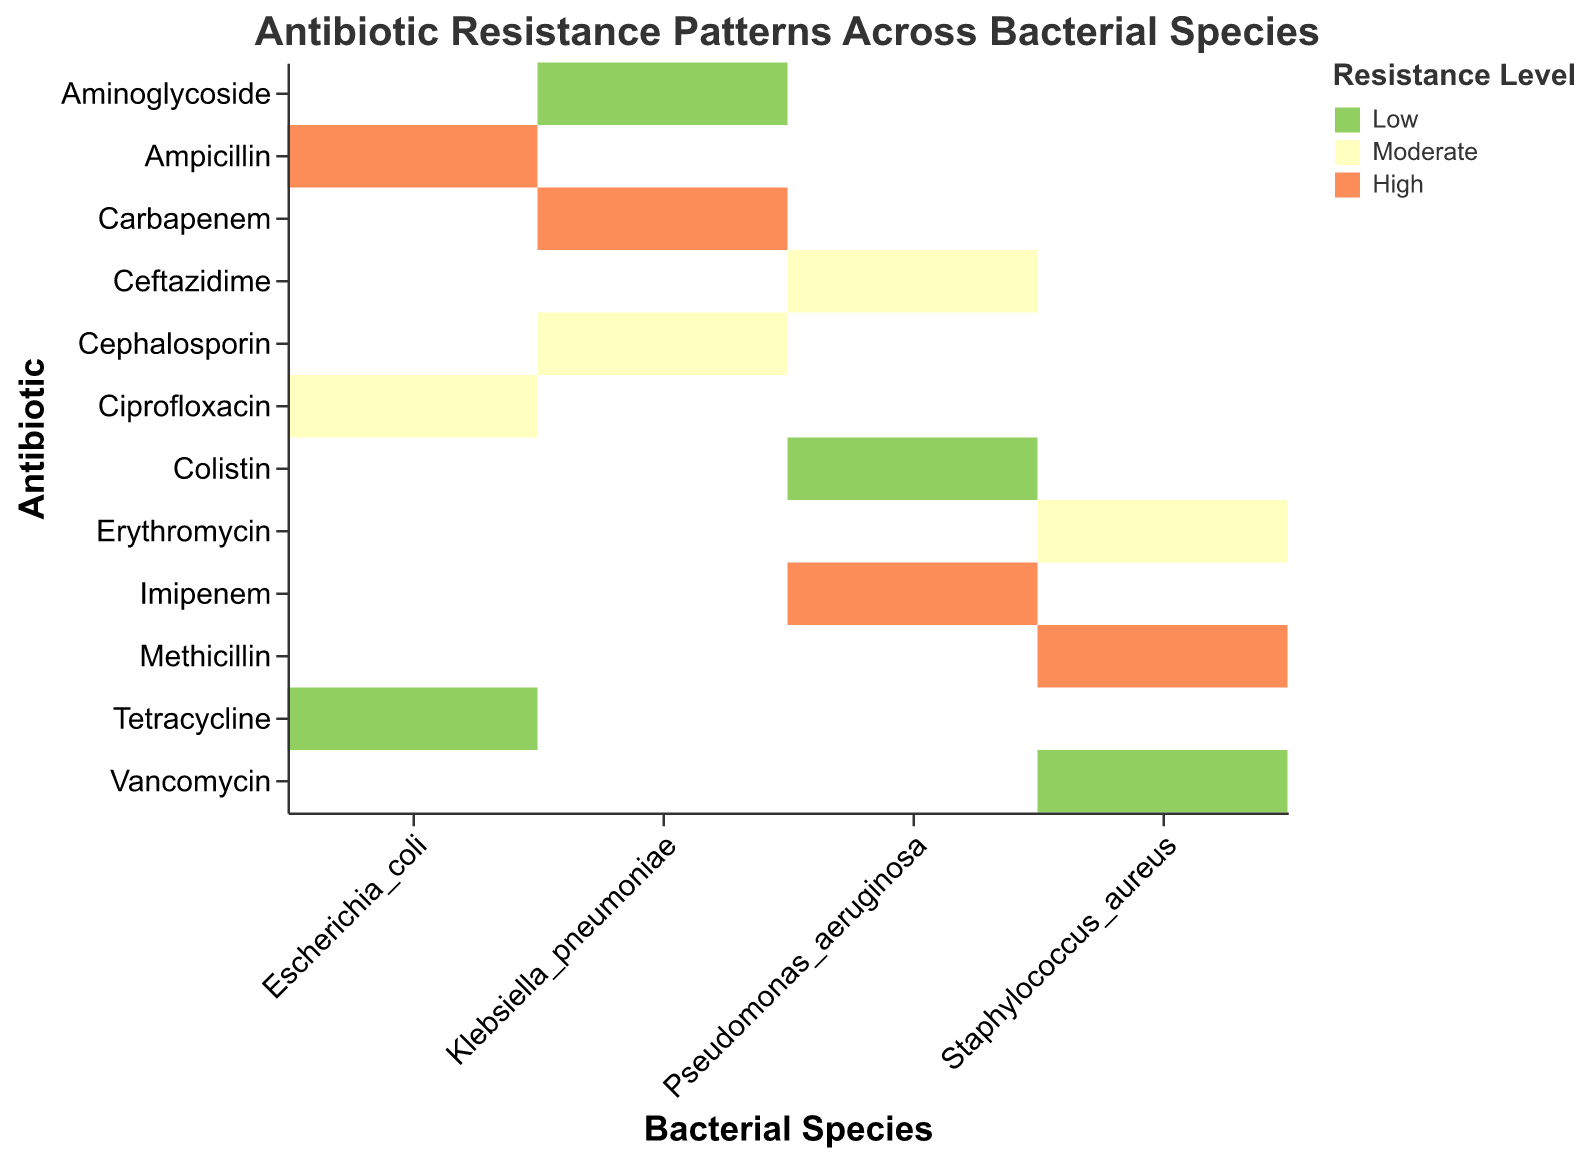Which bacterial species shows high resistance to both Ampicillin and Methicillin? To determine this, look for bars within Escherichia_coli and Staphylococcus_aureus that are colored with the value representing "High" on the Resistance Level.
Answer: None Which antibiotics show moderate resistance for Escherichia_coli? Find the bars within Escherichia_coli that are colored with the value representing "Moderate" on the Resistance Level axis, so the answer is Ciprofloxacin.
Answer: Ciprofloxacin What is the resistance level of Klebsiella_pneumoniae to Aminoglycoside? Identify the square corresponding to Klebsiella_pneumoniae on the Bacterial Species axis and Aminoglycoside on the Antibiotic axis, and note the color representing its Resistance Level, which is Low.
Answer: Low How many bacterial species display moderate resistance to at least one antibiotic? Count the number of bacterial species that have at least one bar colored with the value representing "Moderate" on the Resistance Level. Staphylococcus_aureus, Escherichia_coli, Pseudomonas_aeruginosa, Klebsiella_pneumoniae all meet this condition.
Answer: 4 Which bacterial species has a high resistance to only one antibiotic? Look for bacterial species where only one of their corresponding antibiotics is colored with the value representing "High" on the Resistance Level. Escherichia_coli fits this criterion.
Answer: Escherichia_coli Compare the resistance levels of Staphylococcus_aureus and Pseudomonas_aeruginosa to their respective antibiotics. How do they differ? Compare each bar under Staphylococcus_aureus with the corresponding bars under Pseudomonas_aeruginosa. Both species have 1 Low, 1 Moderate, and 1 High resistance to their respective antibiotics.
Answer: They have identical distributions If you were to sum up all the "High" resistance levels across all bacterial species, how many would you have? Count the total number of bars colored with the value representing "High" across all bacterial species' antibiotics. There are 4 High resistance levels - one each in Escherichia_coli, Staphylococcus_aureus, Pseudomonas_aeruginosa, and Klebsiella_pneumoniae.
Answer: 4 